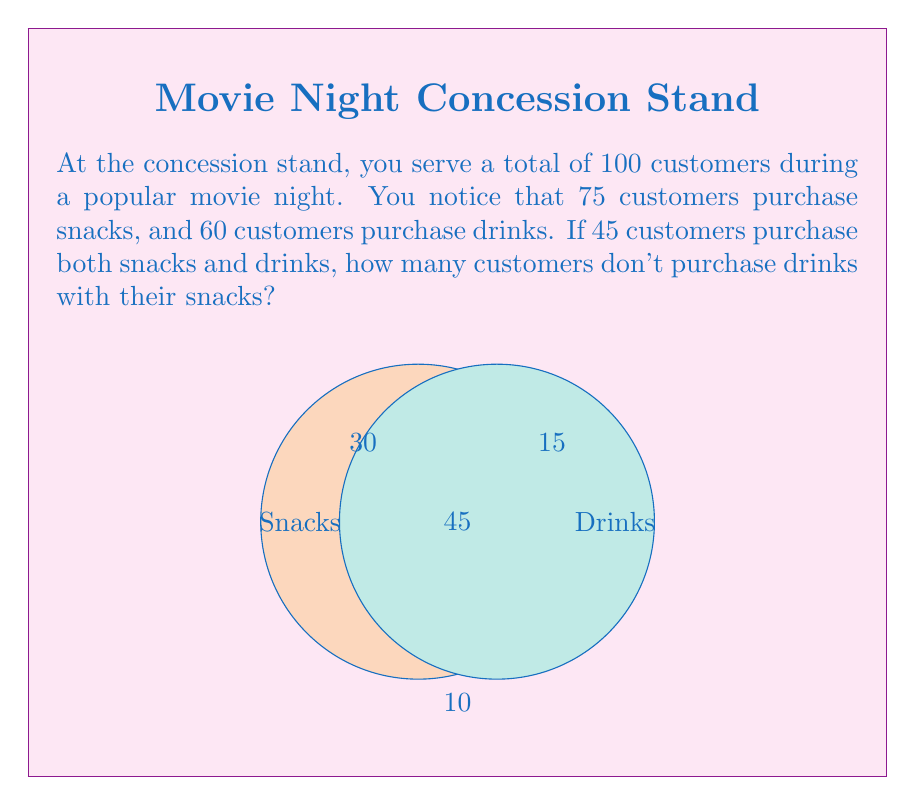Solve this math problem. Let's approach this step-by-step using set theory:

1) Let $S$ be the set of customers who purchase snacks, and $D$ be the set of customers who purchase drinks.

2) We're given:
   - Total customers: $n(U) = 100$
   - Customers who purchase snacks: $n(S) = 75$
   - Customers who purchase drinks: $n(D) = 60$
   - Customers who purchase both: $n(S \cap D) = 45$

3) To find customers who purchase snacks but not drinks, we need to calculate $n(S \setminus D)$.

4) Using the formula: $n(S \cup D) = n(S) + n(D) - n(S \cap D)$
   $n(S \cup D) = 75 + 60 - 45 = 90$

5) Customers who don't purchase snacks or drinks:
   $n(U) - n(S \cup D) = 100 - 90 = 10$

6) Customers who purchase snacks but not drinks:
   $n(S \setminus D) = n(S) - n(S \cap D) = 75 - 45 = 30$

7) Therefore, 30 customers purchase snacks without drinks.

The complement set (those who don't purchase snacks without drinks) would be:
$n(U) - n(S \setminus D) = 100 - 30 = 70$
Answer: 70 customers 